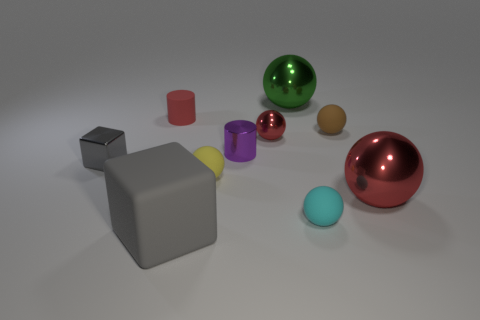Can you describe the spatial arrangement of the objects and its possible significance? The objects in the image are strategically placed to create a balanced composition that draws the viewer's eye across the scene. The larger objects anchor the composition at the center and right, while smaller objects are dispersed throughout to create rhythm and movement. This arrangement might suggest an exploration of scale and perspective, inviting viewers to consider the relationship between object sizes and their placement in a three-dimensional space. 